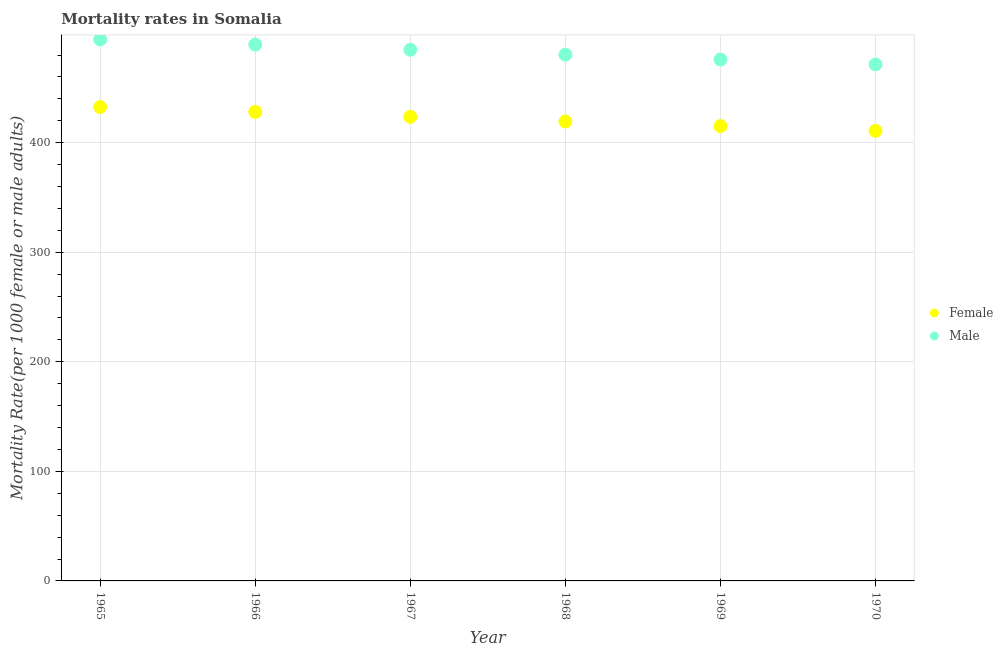Is the number of dotlines equal to the number of legend labels?
Your answer should be very brief. Yes. What is the female mortality rate in 1969?
Provide a succinct answer. 415.12. Across all years, what is the maximum female mortality rate?
Your answer should be very brief. 432.57. Across all years, what is the minimum male mortality rate?
Provide a short and direct response. 471.43. In which year was the male mortality rate maximum?
Your response must be concise. 1965. In which year was the male mortality rate minimum?
Provide a short and direct response. 1970. What is the total female mortality rate in the graph?
Your response must be concise. 2529.63. What is the difference between the female mortality rate in 1965 and that in 1968?
Ensure brevity in your answer.  13.2. What is the difference between the female mortality rate in 1968 and the male mortality rate in 1965?
Offer a terse response. -74.87. What is the average female mortality rate per year?
Provide a succinct answer. 421.61. In the year 1968, what is the difference between the female mortality rate and male mortality rate?
Give a very brief answer. -60.99. What is the ratio of the male mortality rate in 1967 to that in 1969?
Offer a terse response. 1.02. Is the male mortality rate in 1965 less than that in 1967?
Keep it short and to the point. No. Is the difference between the female mortality rate in 1965 and 1968 greater than the difference between the male mortality rate in 1965 and 1968?
Make the answer very short. No. What is the difference between the highest and the second highest female mortality rate?
Ensure brevity in your answer.  4.48. What is the difference between the highest and the lowest male mortality rate?
Keep it short and to the point. 22.81. Does the female mortality rate monotonically increase over the years?
Your response must be concise. No. Is the male mortality rate strictly less than the female mortality rate over the years?
Provide a succinct answer. No. How many dotlines are there?
Make the answer very short. 2. What is the difference between two consecutive major ticks on the Y-axis?
Provide a succinct answer. 100. Are the values on the major ticks of Y-axis written in scientific E-notation?
Your answer should be very brief. No. Does the graph contain any zero values?
Offer a very short reply. No. How many legend labels are there?
Your answer should be compact. 2. What is the title of the graph?
Offer a very short reply. Mortality rates in Somalia. What is the label or title of the X-axis?
Make the answer very short. Year. What is the label or title of the Y-axis?
Provide a short and direct response. Mortality Rate(per 1000 female or male adults). What is the Mortality Rate(per 1000 female or male adults) in Female in 1965?
Make the answer very short. 432.57. What is the Mortality Rate(per 1000 female or male adults) of Male in 1965?
Offer a terse response. 494.24. What is the Mortality Rate(per 1000 female or male adults) of Female in 1966?
Make the answer very short. 428.09. What is the Mortality Rate(per 1000 female or male adults) in Male in 1966?
Your answer should be compact. 489.53. What is the Mortality Rate(per 1000 female or male adults) in Female in 1967?
Provide a succinct answer. 423.62. What is the Mortality Rate(per 1000 female or male adults) in Male in 1967?
Provide a short and direct response. 484.82. What is the Mortality Rate(per 1000 female or male adults) of Female in 1968?
Keep it short and to the point. 419.37. What is the Mortality Rate(per 1000 female or male adults) in Male in 1968?
Offer a very short reply. 480.36. What is the Mortality Rate(per 1000 female or male adults) in Female in 1969?
Your answer should be compact. 415.12. What is the Mortality Rate(per 1000 female or male adults) in Male in 1969?
Offer a very short reply. 475.89. What is the Mortality Rate(per 1000 female or male adults) of Female in 1970?
Your answer should be compact. 410.87. What is the Mortality Rate(per 1000 female or male adults) of Male in 1970?
Keep it short and to the point. 471.43. Across all years, what is the maximum Mortality Rate(per 1000 female or male adults) of Female?
Provide a short and direct response. 432.57. Across all years, what is the maximum Mortality Rate(per 1000 female or male adults) in Male?
Make the answer very short. 494.24. Across all years, what is the minimum Mortality Rate(per 1000 female or male adults) in Female?
Your answer should be compact. 410.87. Across all years, what is the minimum Mortality Rate(per 1000 female or male adults) in Male?
Offer a very short reply. 471.43. What is the total Mortality Rate(per 1000 female or male adults) in Female in the graph?
Your answer should be very brief. 2529.63. What is the total Mortality Rate(per 1000 female or male adults) in Male in the graph?
Provide a succinct answer. 2896.26. What is the difference between the Mortality Rate(per 1000 female or male adults) of Female in 1965 and that in 1966?
Provide a succinct answer. 4.47. What is the difference between the Mortality Rate(per 1000 female or male adults) in Male in 1965 and that in 1966?
Provide a short and direct response. 4.71. What is the difference between the Mortality Rate(per 1000 female or male adults) in Female in 1965 and that in 1967?
Offer a very short reply. 8.95. What is the difference between the Mortality Rate(per 1000 female or male adults) in Male in 1965 and that in 1967?
Your answer should be very brief. 9.41. What is the difference between the Mortality Rate(per 1000 female or male adults) in Female in 1965 and that in 1968?
Your answer should be very brief. 13.2. What is the difference between the Mortality Rate(per 1000 female or male adults) of Male in 1965 and that in 1968?
Your answer should be compact. 13.88. What is the difference between the Mortality Rate(per 1000 female or male adults) of Female in 1965 and that in 1969?
Ensure brevity in your answer.  17.45. What is the difference between the Mortality Rate(per 1000 female or male adults) of Male in 1965 and that in 1969?
Your response must be concise. 18.34. What is the difference between the Mortality Rate(per 1000 female or male adults) in Female in 1965 and that in 1970?
Your response must be concise. 21.7. What is the difference between the Mortality Rate(per 1000 female or male adults) of Male in 1965 and that in 1970?
Your response must be concise. 22.81. What is the difference between the Mortality Rate(per 1000 female or male adults) of Female in 1966 and that in 1967?
Keep it short and to the point. 4.48. What is the difference between the Mortality Rate(per 1000 female or male adults) of Male in 1966 and that in 1967?
Keep it short and to the point. 4.71. What is the difference between the Mortality Rate(per 1000 female or male adults) in Female in 1966 and that in 1968?
Offer a very short reply. 8.73. What is the difference between the Mortality Rate(per 1000 female or male adults) in Male in 1966 and that in 1968?
Your answer should be very brief. 9.17. What is the difference between the Mortality Rate(per 1000 female or male adults) in Female in 1966 and that in 1969?
Provide a succinct answer. 12.98. What is the difference between the Mortality Rate(per 1000 female or male adults) of Male in 1966 and that in 1969?
Your answer should be very brief. 13.64. What is the difference between the Mortality Rate(per 1000 female or male adults) of Female in 1966 and that in 1970?
Your response must be concise. 17.23. What is the difference between the Mortality Rate(per 1000 female or male adults) in Male in 1966 and that in 1970?
Make the answer very short. 18.1. What is the difference between the Mortality Rate(per 1000 female or male adults) of Female in 1967 and that in 1968?
Your answer should be compact. 4.25. What is the difference between the Mortality Rate(per 1000 female or male adults) of Male in 1967 and that in 1968?
Your answer should be very brief. 4.47. What is the difference between the Mortality Rate(per 1000 female or male adults) in Female in 1967 and that in 1969?
Make the answer very short. 8.5. What is the difference between the Mortality Rate(per 1000 female or male adults) in Male in 1967 and that in 1969?
Ensure brevity in your answer.  8.93. What is the difference between the Mortality Rate(per 1000 female or male adults) of Female in 1967 and that in 1970?
Offer a very short reply. 12.75. What is the difference between the Mortality Rate(per 1000 female or male adults) in Male in 1967 and that in 1970?
Make the answer very short. 13.4. What is the difference between the Mortality Rate(per 1000 female or male adults) in Female in 1968 and that in 1969?
Provide a succinct answer. 4.25. What is the difference between the Mortality Rate(per 1000 female or male adults) in Male in 1968 and that in 1969?
Provide a short and direct response. 4.47. What is the difference between the Mortality Rate(per 1000 female or male adults) of Female in 1968 and that in 1970?
Provide a short and direct response. 8.5. What is the difference between the Mortality Rate(per 1000 female or male adults) in Male in 1968 and that in 1970?
Make the answer very short. 8.93. What is the difference between the Mortality Rate(per 1000 female or male adults) in Female in 1969 and that in 1970?
Provide a succinct answer. 4.25. What is the difference between the Mortality Rate(per 1000 female or male adults) in Male in 1969 and that in 1970?
Offer a terse response. 4.47. What is the difference between the Mortality Rate(per 1000 female or male adults) of Female in 1965 and the Mortality Rate(per 1000 female or male adults) of Male in 1966?
Offer a very short reply. -56.96. What is the difference between the Mortality Rate(per 1000 female or male adults) in Female in 1965 and the Mortality Rate(per 1000 female or male adults) in Male in 1967?
Provide a short and direct response. -52.26. What is the difference between the Mortality Rate(per 1000 female or male adults) in Female in 1965 and the Mortality Rate(per 1000 female or male adults) in Male in 1968?
Your response must be concise. -47.79. What is the difference between the Mortality Rate(per 1000 female or male adults) of Female in 1965 and the Mortality Rate(per 1000 female or male adults) of Male in 1969?
Make the answer very short. -43.32. What is the difference between the Mortality Rate(per 1000 female or male adults) in Female in 1965 and the Mortality Rate(per 1000 female or male adults) in Male in 1970?
Your answer should be compact. -38.86. What is the difference between the Mortality Rate(per 1000 female or male adults) of Female in 1966 and the Mortality Rate(per 1000 female or male adults) of Male in 1967?
Your answer should be compact. -56.73. What is the difference between the Mortality Rate(per 1000 female or male adults) in Female in 1966 and the Mortality Rate(per 1000 female or male adults) in Male in 1968?
Your response must be concise. -52.26. What is the difference between the Mortality Rate(per 1000 female or male adults) of Female in 1966 and the Mortality Rate(per 1000 female or male adults) of Male in 1969?
Offer a terse response. -47.8. What is the difference between the Mortality Rate(per 1000 female or male adults) of Female in 1966 and the Mortality Rate(per 1000 female or male adults) of Male in 1970?
Give a very brief answer. -43.33. What is the difference between the Mortality Rate(per 1000 female or male adults) of Female in 1967 and the Mortality Rate(per 1000 female or male adults) of Male in 1968?
Your response must be concise. -56.74. What is the difference between the Mortality Rate(per 1000 female or male adults) in Female in 1967 and the Mortality Rate(per 1000 female or male adults) in Male in 1969?
Offer a very short reply. -52.27. What is the difference between the Mortality Rate(per 1000 female or male adults) of Female in 1967 and the Mortality Rate(per 1000 female or male adults) of Male in 1970?
Give a very brief answer. -47.81. What is the difference between the Mortality Rate(per 1000 female or male adults) of Female in 1968 and the Mortality Rate(per 1000 female or male adults) of Male in 1969?
Offer a very short reply. -56.52. What is the difference between the Mortality Rate(per 1000 female or male adults) of Female in 1968 and the Mortality Rate(per 1000 female or male adults) of Male in 1970?
Ensure brevity in your answer.  -52.06. What is the difference between the Mortality Rate(per 1000 female or male adults) in Female in 1969 and the Mortality Rate(per 1000 female or male adults) in Male in 1970?
Offer a very short reply. -56.31. What is the average Mortality Rate(per 1000 female or male adults) in Female per year?
Keep it short and to the point. 421.61. What is the average Mortality Rate(per 1000 female or male adults) in Male per year?
Provide a short and direct response. 482.71. In the year 1965, what is the difference between the Mortality Rate(per 1000 female or male adults) in Female and Mortality Rate(per 1000 female or male adults) in Male?
Ensure brevity in your answer.  -61.67. In the year 1966, what is the difference between the Mortality Rate(per 1000 female or male adults) of Female and Mortality Rate(per 1000 female or male adults) of Male?
Give a very brief answer. -61.44. In the year 1967, what is the difference between the Mortality Rate(per 1000 female or male adults) in Female and Mortality Rate(per 1000 female or male adults) in Male?
Ensure brevity in your answer.  -61.21. In the year 1968, what is the difference between the Mortality Rate(per 1000 female or male adults) in Female and Mortality Rate(per 1000 female or male adults) in Male?
Provide a short and direct response. -60.99. In the year 1969, what is the difference between the Mortality Rate(per 1000 female or male adults) in Female and Mortality Rate(per 1000 female or male adults) in Male?
Ensure brevity in your answer.  -60.77. In the year 1970, what is the difference between the Mortality Rate(per 1000 female or male adults) of Female and Mortality Rate(per 1000 female or male adults) of Male?
Ensure brevity in your answer.  -60.56. What is the ratio of the Mortality Rate(per 1000 female or male adults) in Female in 1965 to that in 1966?
Make the answer very short. 1.01. What is the ratio of the Mortality Rate(per 1000 female or male adults) in Male in 1965 to that in 1966?
Ensure brevity in your answer.  1.01. What is the ratio of the Mortality Rate(per 1000 female or male adults) in Female in 1965 to that in 1967?
Ensure brevity in your answer.  1.02. What is the ratio of the Mortality Rate(per 1000 female or male adults) of Male in 1965 to that in 1967?
Your response must be concise. 1.02. What is the ratio of the Mortality Rate(per 1000 female or male adults) in Female in 1965 to that in 1968?
Keep it short and to the point. 1.03. What is the ratio of the Mortality Rate(per 1000 female or male adults) in Male in 1965 to that in 1968?
Ensure brevity in your answer.  1.03. What is the ratio of the Mortality Rate(per 1000 female or male adults) of Female in 1965 to that in 1969?
Offer a very short reply. 1.04. What is the ratio of the Mortality Rate(per 1000 female or male adults) in Female in 1965 to that in 1970?
Offer a very short reply. 1.05. What is the ratio of the Mortality Rate(per 1000 female or male adults) in Male in 1965 to that in 1970?
Make the answer very short. 1.05. What is the ratio of the Mortality Rate(per 1000 female or male adults) in Female in 1966 to that in 1967?
Your answer should be compact. 1.01. What is the ratio of the Mortality Rate(per 1000 female or male adults) of Male in 1966 to that in 1967?
Keep it short and to the point. 1.01. What is the ratio of the Mortality Rate(per 1000 female or male adults) of Female in 1966 to that in 1968?
Give a very brief answer. 1.02. What is the ratio of the Mortality Rate(per 1000 female or male adults) of Male in 1966 to that in 1968?
Your response must be concise. 1.02. What is the ratio of the Mortality Rate(per 1000 female or male adults) in Female in 1966 to that in 1969?
Provide a succinct answer. 1.03. What is the ratio of the Mortality Rate(per 1000 female or male adults) of Male in 1966 to that in 1969?
Provide a short and direct response. 1.03. What is the ratio of the Mortality Rate(per 1000 female or male adults) of Female in 1966 to that in 1970?
Provide a succinct answer. 1.04. What is the ratio of the Mortality Rate(per 1000 female or male adults) in Male in 1966 to that in 1970?
Keep it short and to the point. 1.04. What is the ratio of the Mortality Rate(per 1000 female or male adults) of Female in 1967 to that in 1968?
Keep it short and to the point. 1.01. What is the ratio of the Mortality Rate(per 1000 female or male adults) in Male in 1967 to that in 1968?
Your answer should be very brief. 1.01. What is the ratio of the Mortality Rate(per 1000 female or male adults) of Female in 1967 to that in 1969?
Ensure brevity in your answer.  1.02. What is the ratio of the Mortality Rate(per 1000 female or male adults) in Male in 1967 to that in 1969?
Your answer should be compact. 1.02. What is the ratio of the Mortality Rate(per 1000 female or male adults) of Female in 1967 to that in 1970?
Make the answer very short. 1.03. What is the ratio of the Mortality Rate(per 1000 female or male adults) in Male in 1967 to that in 1970?
Make the answer very short. 1.03. What is the ratio of the Mortality Rate(per 1000 female or male adults) of Female in 1968 to that in 1969?
Your answer should be compact. 1.01. What is the ratio of the Mortality Rate(per 1000 female or male adults) of Male in 1968 to that in 1969?
Offer a terse response. 1.01. What is the ratio of the Mortality Rate(per 1000 female or male adults) in Female in 1968 to that in 1970?
Ensure brevity in your answer.  1.02. What is the ratio of the Mortality Rate(per 1000 female or male adults) in Male in 1968 to that in 1970?
Your answer should be very brief. 1.02. What is the ratio of the Mortality Rate(per 1000 female or male adults) of Female in 1969 to that in 1970?
Your answer should be compact. 1.01. What is the ratio of the Mortality Rate(per 1000 female or male adults) in Male in 1969 to that in 1970?
Keep it short and to the point. 1.01. What is the difference between the highest and the second highest Mortality Rate(per 1000 female or male adults) in Female?
Your response must be concise. 4.47. What is the difference between the highest and the second highest Mortality Rate(per 1000 female or male adults) in Male?
Give a very brief answer. 4.71. What is the difference between the highest and the lowest Mortality Rate(per 1000 female or male adults) of Female?
Offer a very short reply. 21.7. What is the difference between the highest and the lowest Mortality Rate(per 1000 female or male adults) in Male?
Offer a terse response. 22.81. 